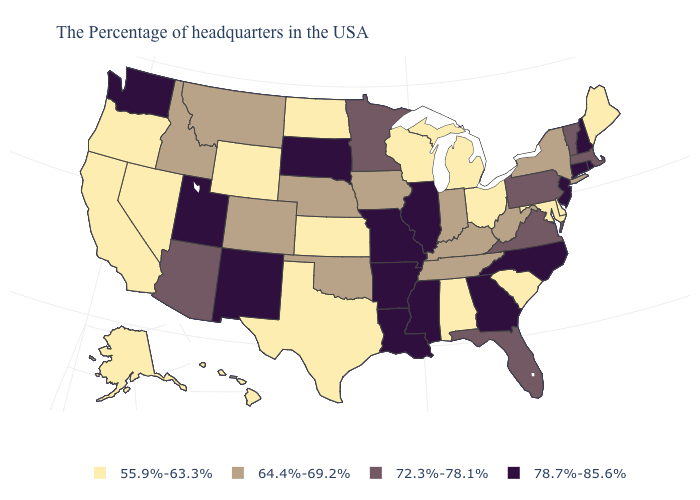Name the states that have a value in the range 64.4%-69.2%?
Short answer required. New York, West Virginia, Kentucky, Indiana, Tennessee, Iowa, Nebraska, Oklahoma, Colorado, Montana, Idaho. What is the value of Ohio?
Short answer required. 55.9%-63.3%. Name the states that have a value in the range 55.9%-63.3%?
Concise answer only. Maine, Delaware, Maryland, South Carolina, Ohio, Michigan, Alabama, Wisconsin, Kansas, Texas, North Dakota, Wyoming, Nevada, California, Oregon, Alaska, Hawaii. What is the lowest value in the USA?
Answer briefly. 55.9%-63.3%. Which states have the lowest value in the West?
Give a very brief answer. Wyoming, Nevada, California, Oregon, Alaska, Hawaii. Does Delaware have a lower value than Texas?
Give a very brief answer. No. What is the value of Oregon?
Answer briefly. 55.9%-63.3%. What is the value of Nebraska?
Be succinct. 64.4%-69.2%. What is the lowest value in states that border South Dakota?
Be succinct. 55.9%-63.3%. What is the value of Florida?
Short answer required. 72.3%-78.1%. What is the value of Arizona?
Give a very brief answer. 72.3%-78.1%. Name the states that have a value in the range 55.9%-63.3%?
Concise answer only. Maine, Delaware, Maryland, South Carolina, Ohio, Michigan, Alabama, Wisconsin, Kansas, Texas, North Dakota, Wyoming, Nevada, California, Oregon, Alaska, Hawaii. What is the value of Michigan?
Quick response, please. 55.9%-63.3%. What is the highest value in the MidWest ?
Short answer required. 78.7%-85.6%. What is the value of New Jersey?
Concise answer only. 78.7%-85.6%. 